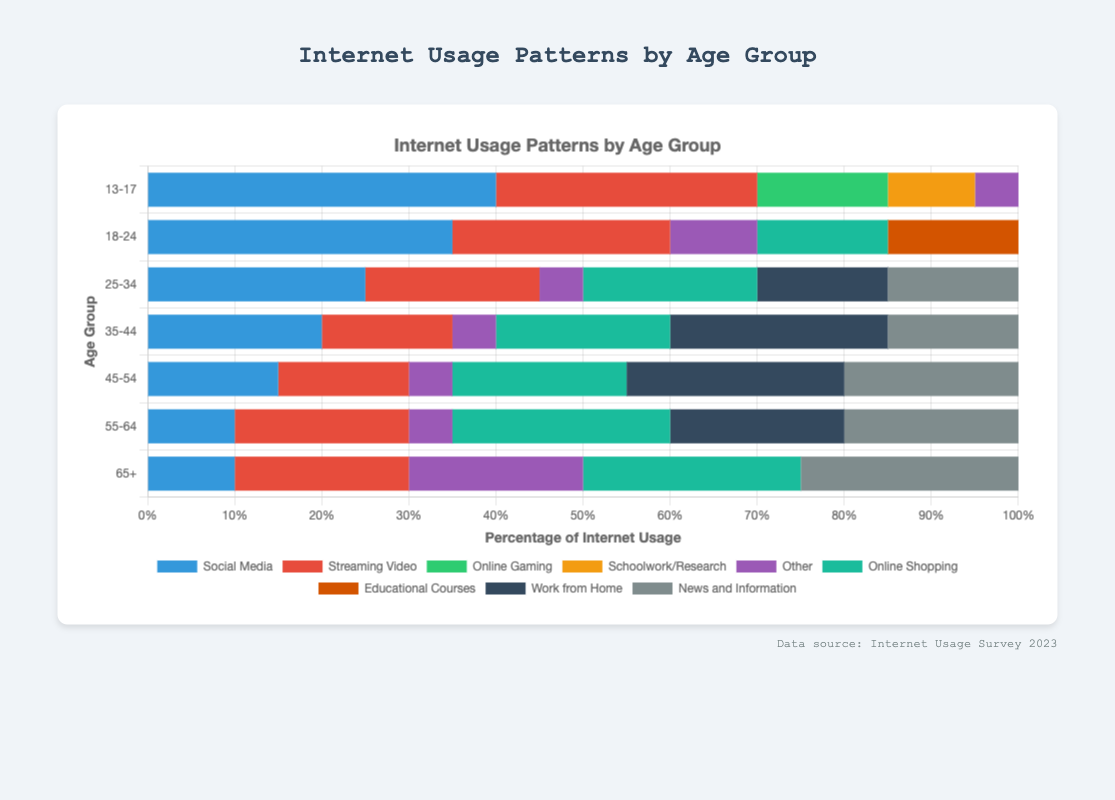Which age group spends the highest percentage of their internet usage on Social Media? Look at the Social Media segment for each age group and identify the one with the highest percentage. The age group 13-17 has the highest percentage at 40%.
Answer: 13-17 What is the combined percentage usage of News and Information and Work from Home activities for the 45-54 age group? Add up the percentages for News and Information (20%) and Work from Home (25%) for the 45-54 age group. 20 + 25 = 45%.
Answer: 45% How does the percentage of Online Shopping differ between the age groups 25-34 and 55-64? Subtract the percentage of Online Shopping for the 25-34 group (20%) from the 55-64 group (25%). 25 - 20 = 5%.
Answer: 5% Which age group has the most balanced usage distribution across all activities (i.e., the smallest difference between the highest and lowest percentage)? Calculate the difference between the highest and lowest percentages for each age group and identify the smallest difference. For 18-24, the highest is 35% (Social Media) and the lowest is 10% (Other), with a difference of 25%. For 25-34, it’s 25% (Social Media) and 5% (Other), with a difference of 20%. Continue this for all groups. The age group 25-34 has the most balanced distribution with a difference of 20%.
Answer: 25-34 What is the least popular activity for the age group 13-17? Referring to the percentages of each activity for the 13-17 age group, the activity with the lowest percentage is Other at 5%.
Answer: Other How much more percentage of internet usage does the age group 35-44 spend on Work from Home compared to Streaming Video? Subtract the Streaming Video percentage (15%) from the Work from Home percentage (25%) for the age group 35-44. 25 - 15 = 10%.
Answer: 10% Which age group spends a higher percentage of their internet usage on Streaming Video: 13-17 or 18-24? Compare the Streaming Video percentages between the two age groups. For 13-17, it is 30%, and for 18-24, it is 25%. The 13-17 age group spends more.
Answer: 13-17 For the age group 65+, what percentage of internet usage is attributed to activities excluding Other? Subtract the percentage for Other (20%) from 100% to find the percentage for all other activities combined. 100 - 20 = 80%.
Answer: 80% Which activity has the largest percentage difference between the age groups 13-17 and 25-34? Calculate the difference for each activity between the age groups. For Social Media: 40% (13-17) - 25% (25-34) = 15%. Continue this method for each activity. Social Media has the largest difference of 15%.
Answer: Social Media 